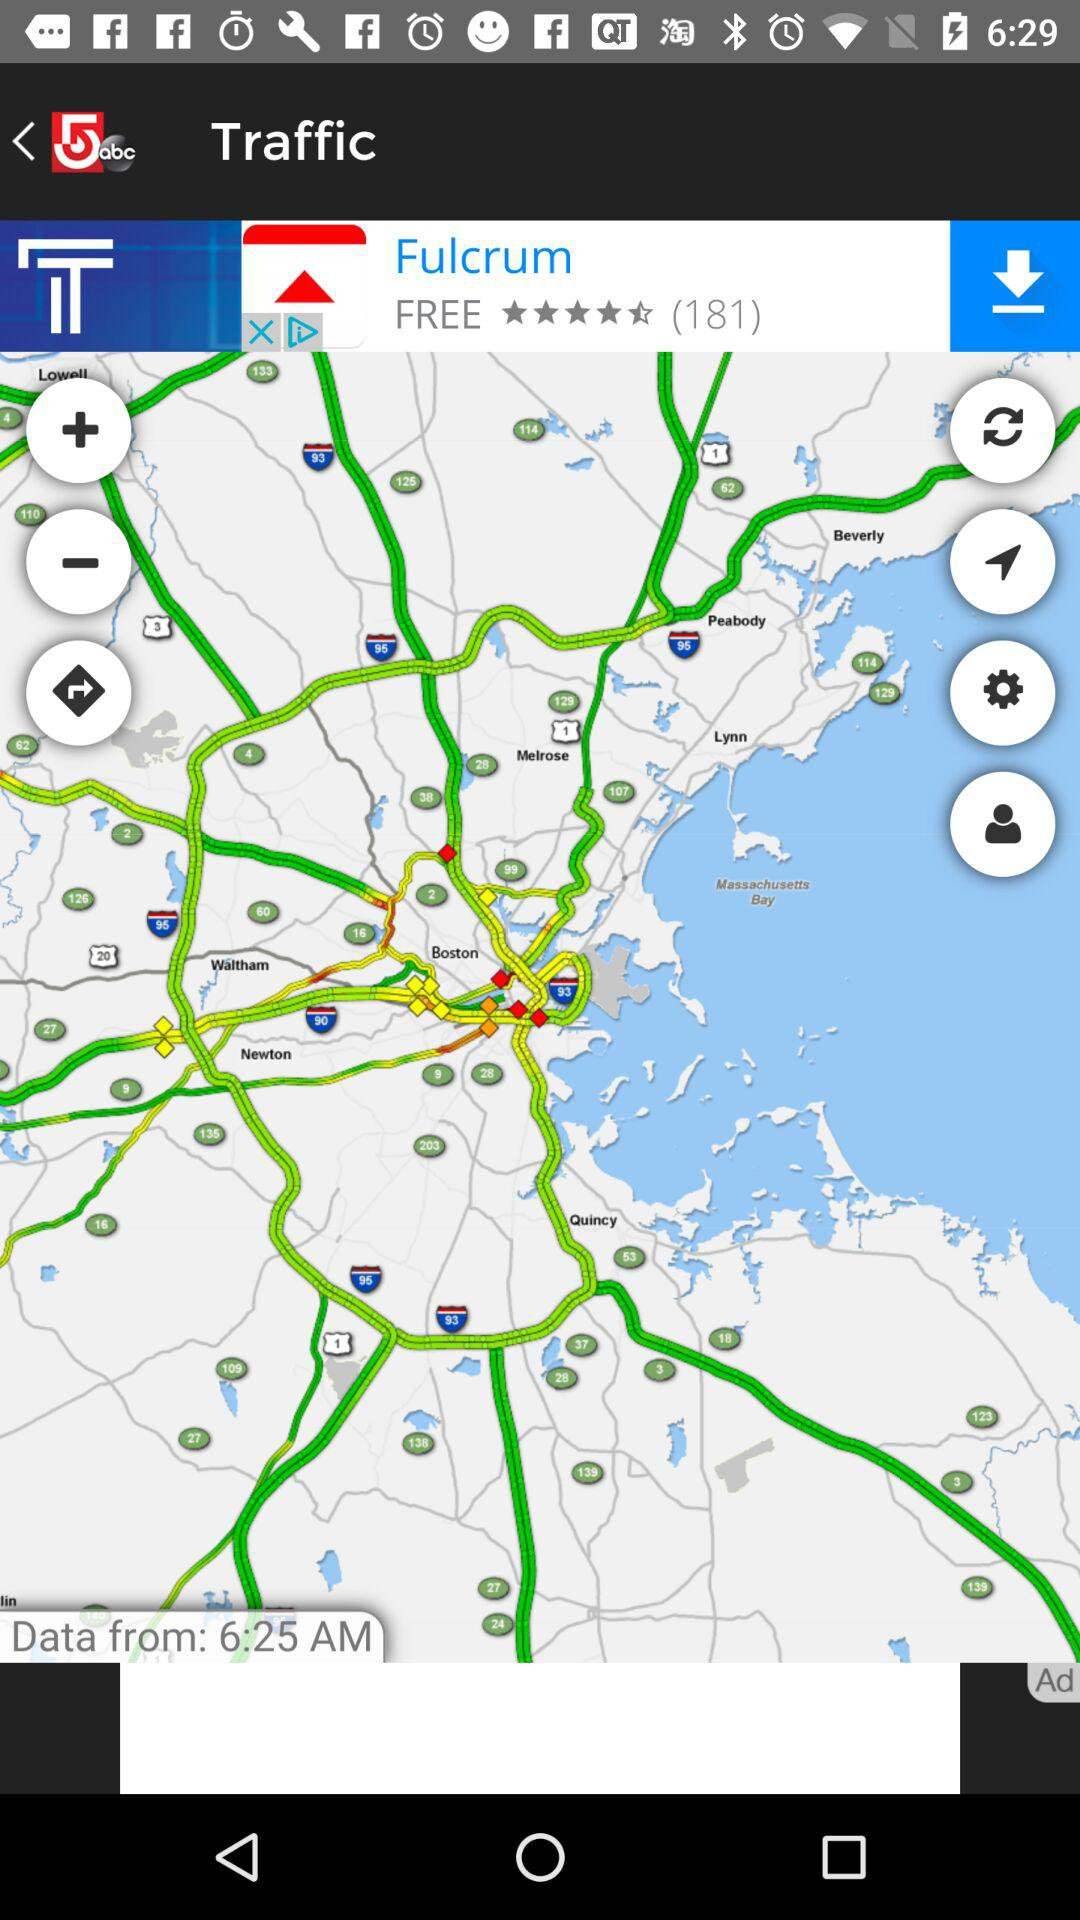At what time was the data updated? The data was updated at 6:25 AM. 